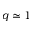Convert formula to latex. <formula><loc_0><loc_0><loc_500><loc_500>q \simeq 1</formula> 